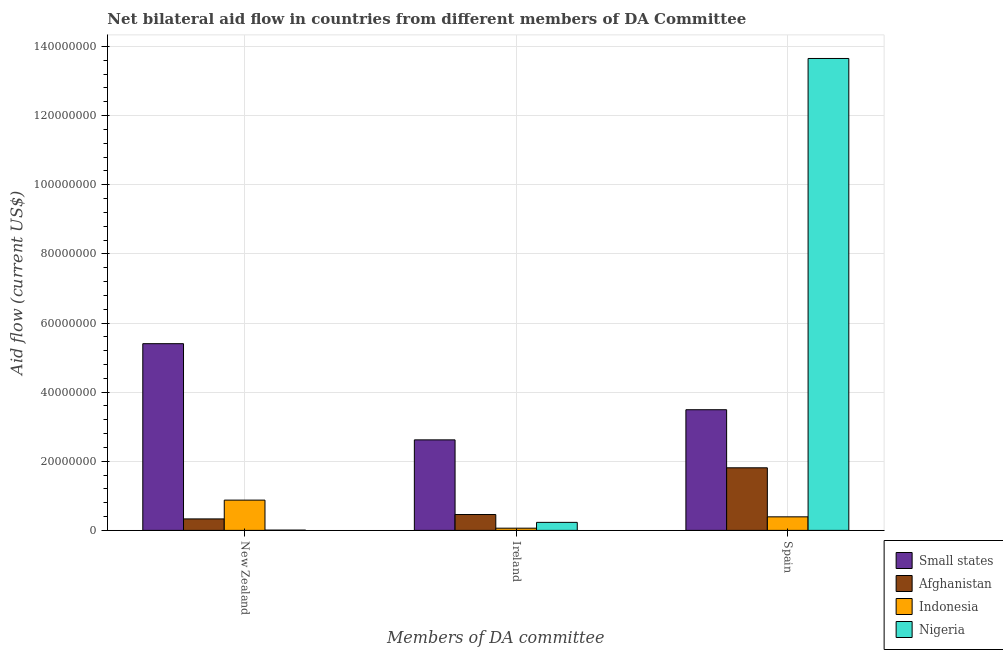How many different coloured bars are there?
Provide a short and direct response. 4. Are the number of bars per tick equal to the number of legend labels?
Ensure brevity in your answer.  Yes. Are the number of bars on each tick of the X-axis equal?
Offer a very short reply. Yes. How many bars are there on the 3rd tick from the right?
Make the answer very short. 4. What is the label of the 2nd group of bars from the left?
Your answer should be compact. Ireland. What is the amount of aid provided by ireland in Small states?
Make the answer very short. 2.62e+07. Across all countries, what is the maximum amount of aid provided by ireland?
Your answer should be compact. 2.62e+07. Across all countries, what is the minimum amount of aid provided by ireland?
Keep it short and to the point. 6.40e+05. In which country was the amount of aid provided by ireland maximum?
Make the answer very short. Small states. What is the total amount of aid provided by new zealand in the graph?
Your answer should be compact. 6.62e+07. What is the difference between the amount of aid provided by spain in Nigeria and that in Indonesia?
Ensure brevity in your answer.  1.33e+08. What is the difference between the amount of aid provided by spain in Indonesia and the amount of aid provided by ireland in Afghanistan?
Offer a terse response. -6.70e+05. What is the average amount of aid provided by ireland per country?
Give a very brief answer. 8.44e+06. What is the difference between the amount of aid provided by spain and amount of aid provided by new zealand in Afghanistan?
Your response must be concise. 1.48e+07. What is the ratio of the amount of aid provided by new zealand in Small states to that in Nigeria?
Provide a succinct answer. 675.25. What is the difference between the highest and the second highest amount of aid provided by new zealand?
Give a very brief answer. 4.53e+07. What is the difference between the highest and the lowest amount of aid provided by ireland?
Ensure brevity in your answer.  2.56e+07. Is the sum of the amount of aid provided by ireland in Afghanistan and Small states greater than the maximum amount of aid provided by new zealand across all countries?
Your answer should be very brief. No. What does the 1st bar from the left in Spain represents?
Ensure brevity in your answer.  Small states. What does the 1st bar from the right in New Zealand represents?
Ensure brevity in your answer.  Nigeria. Is it the case that in every country, the sum of the amount of aid provided by new zealand and amount of aid provided by ireland is greater than the amount of aid provided by spain?
Keep it short and to the point. No. Are all the bars in the graph horizontal?
Your answer should be very brief. No. How many countries are there in the graph?
Give a very brief answer. 4. What is the difference between two consecutive major ticks on the Y-axis?
Provide a short and direct response. 2.00e+07. Are the values on the major ticks of Y-axis written in scientific E-notation?
Ensure brevity in your answer.  No. How many legend labels are there?
Your answer should be very brief. 4. What is the title of the graph?
Offer a very short reply. Net bilateral aid flow in countries from different members of DA Committee. What is the label or title of the X-axis?
Make the answer very short. Members of DA committee. What is the label or title of the Y-axis?
Your response must be concise. Aid flow (current US$). What is the Aid flow (current US$) in Small states in New Zealand?
Offer a very short reply. 5.40e+07. What is the Aid flow (current US$) of Afghanistan in New Zealand?
Your answer should be very brief. 3.32e+06. What is the Aid flow (current US$) of Indonesia in New Zealand?
Your response must be concise. 8.76e+06. What is the Aid flow (current US$) of Nigeria in New Zealand?
Your answer should be very brief. 8.00e+04. What is the Aid flow (current US$) in Small states in Ireland?
Offer a terse response. 2.62e+07. What is the Aid flow (current US$) of Afghanistan in Ireland?
Make the answer very short. 4.59e+06. What is the Aid flow (current US$) in Indonesia in Ireland?
Your answer should be compact. 6.40e+05. What is the Aid flow (current US$) of Nigeria in Ireland?
Offer a terse response. 2.32e+06. What is the Aid flow (current US$) in Small states in Spain?
Keep it short and to the point. 3.49e+07. What is the Aid flow (current US$) in Afghanistan in Spain?
Make the answer very short. 1.81e+07. What is the Aid flow (current US$) in Indonesia in Spain?
Give a very brief answer. 3.92e+06. What is the Aid flow (current US$) of Nigeria in Spain?
Ensure brevity in your answer.  1.37e+08. Across all Members of DA committee, what is the maximum Aid flow (current US$) in Small states?
Your answer should be very brief. 5.40e+07. Across all Members of DA committee, what is the maximum Aid flow (current US$) of Afghanistan?
Keep it short and to the point. 1.81e+07. Across all Members of DA committee, what is the maximum Aid flow (current US$) of Indonesia?
Ensure brevity in your answer.  8.76e+06. Across all Members of DA committee, what is the maximum Aid flow (current US$) of Nigeria?
Offer a terse response. 1.37e+08. Across all Members of DA committee, what is the minimum Aid flow (current US$) of Small states?
Make the answer very short. 2.62e+07. Across all Members of DA committee, what is the minimum Aid flow (current US$) in Afghanistan?
Provide a short and direct response. 3.32e+06. Across all Members of DA committee, what is the minimum Aid flow (current US$) in Indonesia?
Make the answer very short. 6.40e+05. What is the total Aid flow (current US$) in Small states in the graph?
Offer a terse response. 1.15e+08. What is the total Aid flow (current US$) of Afghanistan in the graph?
Your answer should be compact. 2.60e+07. What is the total Aid flow (current US$) of Indonesia in the graph?
Provide a short and direct response. 1.33e+07. What is the total Aid flow (current US$) of Nigeria in the graph?
Offer a very short reply. 1.39e+08. What is the difference between the Aid flow (current US$) of Small states in New Zealand and that in Ireland?
Your response must be concise. 2.78e+07. What is the difference between the Aid flow (current US$) of Afghanistan in New Zealand and that in Ireland?
Provide a short and direct response. -1.27e+06. What is the difference between the Aid flow (current US$) of Indonesia in New Zealand and that in Ireland?
Your answer should be compact. 8.12e+06. What is the difference between the Aid flow (current US$) in Nigeria in New Zealand and that in Ireland?
Your answer should be very brief. -2.24e+06. What is the difference between the Aid flow (current US$) in Small states in New Zealand and that in Spain?
Ensure brevity in your answer.  1.91e+07. What is the difference between the Aid flow (current US$) of Afghanistan in New Zealand and that in Spain?
Keep it short and to the point. -1.48e+07. What is the difference between the Aid flow (current US$) of Indonesia in New Zealand and that in Spain?
Provide a succinct answer. 4.84e+06. What is the difference between the Aid flow (current US$) in Nigeria in New Zealand and that in Spain?
Offer a terse response. -1.36e+08. What is the difference between the Aid flow (current US$) in Small states in Ireland and that in Spain?
Keep it short and to the point. -8.72e+06. What is the difference between the Aid flow (current US$) of Afghanistan in Ireland and that in Spain?
Provide a succinct answer. -1.35e+07. What is the difference between the Aid flow (current US$) of Indonesia in Ireland and that in Spain?
Offer a terse response. -3.28e+06. What is the difference between the Aid flow (current US$) of Nigeria in Ireland and that in Spain?
Offer a very short reply. -1.34e+08. What is the difference between the Aid flow (current US$) in Small states in New Zealand and the Aid flow (current US$) in Afghanistan in Ireland?
Give a very brief answer. 4.94e+07. What is the difference between the Aid flow (current US$) of Small states in New Zealand and the Aid flow (current US$) of Indonesia in Ireland?
Provide a short and direct response. 5.34e+07. What is the difference between the Aid flow (current US$) of Small states in New Zealand and the Aid flow (current US$) of Nigeria in Ireland?
Keep it short and to the point. 5.17e+07. What is the difference between the Aid flow (current US$) in Afghanistan in New Zealand and the Aid flow (current US$) in Indonesia in Ireland?
Make the answer very short. 2.68e+06. What is the difference between the Aid flow (current US$) in Indonesia in New Zealand and the Aid flow (current US$) in Nigeria in Ireland?
Make the answer very short. 6.44e+06. What is the difference between the Aid flow (current US$) of Small states in New Zealand and the Aid flow (current US$) of Afghanistan in Spain?
Make the answer very short. 3.59e+07. What is the difference between the Aid flow (current US$) in Small states in New Zealand and the Aid flow (current US$) in Indonesia in Spain?
Your response must be concise. 5.01e+07. What is the difference between the Aid flow (current US$) of Small states in New Zealand and the Aid flow (current US$) of Nigeria in Spain?
Your response must be concise. -8.25e+07. What is the difference between the Aid flow (current US$) of Afghanistan in New Zealand and the Aid flow (current US$) of Indonesia in Spain?
Your answer should be very brief. -6.00e+05. What is the difference between the Aid flow (current US$) in Afghanistan in New Zealand and the Aid flow (current US$) in Nigeria in Spain?
Provide a short and direct response. -1.33e+08. What is the difference between the Aid flow (current US$) in Indonesia in New Zealand and the Aid flow (current US$) in Nigeria in Spain?
Your response must be concise. -1.28e+08. What is the difference between the Aid flow (current US$) of Small states in Ireland and the Aid flow (current US$) of Afghanistan in Spain?
Make the answer very short. 8.08e+06. What is the difference between the Aid flow (current US$) of Small states in Ireland and the Aid flow (current US$) of Indonesia in Spain?
Provide a short and direct response. 2.23e+07. What is the difference between the Aid flow (current US$) in Small states in Ireland and the Aid flow (current US$) in Nigeria in Spain?
Ensure brevity in your answer.  -1.10e+08. What is the difference between the Aid flow (current US$) in Afghanistan in Ireland and the Aid flow (current US$) in Indonesia in Spain?
Offer a terse response. 6.70e+05. What is the difference between the Aid flow (current US$) of Afghanistan in Ireland and the Aid flow (current US$) of Nigeria in Spain?
Your response must be concise. -1.32e+08. What is the difference between the Aid flow (current US$) of Indonesia in Ireland and the Aid flow (current US$) of Nigeria in Spain?
Give a very brief answer. -1.36e+08. What is the average Aid flow (current US$) in Small states per Members of DA committee?
Provide a succinct answer. 3.84e+07. What is the average Aid flow (current US$) in Afghanistan per Members of DA committee?
Your answer should be very brief. 8.67e+06. What is the average Aid flow (current US$) in Indonesia per Members of DA committee?
Your answer should be very brief. 4.44e+06. What is the average Aid flow (current US$) of Nigeria per Members of DA committee?
Provide a succinct answer. 4.63e+07. What is the difference between the Aid flow (current US$) of Small states and Aid flow (current US$) of Afghanistan in New Zealand?
Provide a short and direct response. 5.07e+07. What is the difference between the Aid flow (current US$) of Small states and Aid flow (current US$) of Indonesia in New Zealand?
Give a very brief answer. 4.53e+07. What is the difference between the Aid flow (current US$) of Small states and Aid flow (current US$) of Nigeria in New Zealand?
Offer a terse response. 5.39e+07. What is the difference between the Aid flow (current US$) in Afghanistan and Aid flow (current US$) in Indonesia in New Zealand?
Your answer should be compact. -5.44e+06. What is the difference between the Aid flow (current US$) of Afghanistan and Aid flow (current US$) of Nigeria in New Zealand?
Keep it short and to the point. 3.24e+06. What is the difference between the Aid flow (current US$) in Indonesia and Aid flow (current US$) in Nigeria in New Zealand?
Your answer should be compact. 8.68e+06. What is the difference between the Aid flow (current US$) of Small states and Aid flow (current US$) of Afghanistan in Ireland?
Your response must be concise. 2.16e+07. What is the difference between the Aid flow (current US$) of Small states and Aid flow (current US$) of Indonesia in Ireland?
Your answer should be very brief. 2.56e+07. What is the difference between the Aid flow (current US$) in Small states and Aid flow (current US$) in Nigeria in Ireland?
Offer a very short reply. 2.39e+07. What is the difference between the Aid flow (current US$) of Afghanistan and Aid flow (current US$) of Indonesia in Ireland?
Your response must be concise. 3.95e+06. What is the difference between the Aid flow (current US$) in Afghanistan and Aid flow (current US$) in Nigeria in Ireland?
Provide a succinct answer. 2.27e+06. What is the difference between the Aid flow (current US$) of Indonesia and Aid flow (current US$) of Nigeria in Ireland?
Provide a short and direct response. -1.68e+06. What is the difference between the Aid flow (current US$) of Small states and Aid flow (current US$) of Afghanistan in Spain?
Provide a short and direct response. 1.68e+07. What is the difference between the Aid flow (current US$) in Small states and Aid flow (current US$) in Indonesia in Spain?
Give a very brief answer. 3.10e+07. What is the difference between the Aid flow (current US$) in Small states and Aid flow (current US$) in Nigeria in Spain?
Your answer should be compact. -1.02e+08. What is the difference between the Aid flow (current US$) of Afghanistan and Aid flow (current US$) of Indonesia in Spain?
Make the answer very short. 1.42e+07. What is the difference between the Aid flow (current US$) in Afghanistan and Aid flow (current US$) in Nigeria in Spain?
Give a very brief answer. -1.18e+08. What is the difference between the Aid flow (current US$) of Indonesia and Aid flow (current US$) of Nigeria in Spain?
Keep it short and to the point. -1.33e+08. What is the ratio of the Aid flow (current US$) in Small states in New Zealand to that in Ireland?
Make the answer very short. 2.06. What is the ratio of the Aid flow (current US$) in Afghanistan in New Zealand to that in Ireland?
Keep it short and to the point. 0.72. What is the ratio of the Aid flow (current US$) in Indonesia in New Zealand to that in Ireland?
Provide a succinct answer. 13.69. What is the ratio of the Aid flow (current US$) of Nigeria in New Zealand to that in Ireland?
Give a very brief answer. 0.03. What is the ratio of the Aid flow (current US$) in Small states in New Zealand to that in Spain?
Provide a short and direct response. 1.55. What is the ratio of the Aid flow (current US$) of Afghanistan in New Zealand to that in Spain?
Give a very brief answer. 0.18. What is the ratio of the Aid flow (current US$) of Indonesia in New Zealand to that in Spain?
Your answer should be very brief. 2.23. What is the ratio of the Aid flow (current US$) of Nigeria in New Zealand to that in Spain?
Provide a short and direct response. 0. What is the ratio of the Aid flow (current US$) in Small states in Ireland to that in Spain?
Make the answer very short. 0.75. What is the ratio of the Aid flow (current US$) of Afghanistan in Ireland to that in Spain?
Provide a short and direct response. 0.25. What is the ratio of the Aid flow (current US$) of Indonesia in Ireland to that in Spain?
Your response must be concise. 0.16. What is the ratio of the Aid flow (current US$) of Nigeria in Ireland to that in Spain?
Your response must be concise. 0.02. What is the difference between the highest and the second highest Aid flow (current US$) in Small states?
Ensure brevity in your answer.  1.91e+07. What is the difference between the highest and the second highest Aid flow (current US$) in Afghanistan?
Offer a terse response. 1.35e+07. What is the difference between the highest and the second highest Aid flow (current US$) in Indonesia?
Offer a very short reply. 4.84e+06. What is the difference between the highest and the second highest Aid flow (current US$) in Nigeria?
Keep it short and to the point. 1.34e+08. What is the difference between the highest and the lowest Aid flow (current US$) of Small states?
Your answer should be compact. 2.78e+07. What is the difference between the highest and the lowest Aid flow (current US$) in Afghanistan?
Ensure brevity in your answer.  1.48e+07. What is the difference between the highest and the lowest Aid flow (current US$) in Indonesia?
Provide a succinct answer. 8.12e+06. What is the difference between the highest and the lowest Aid flow (current US$) in Nigeria?
Ensure brevity in your answer.  1.36e+08. 